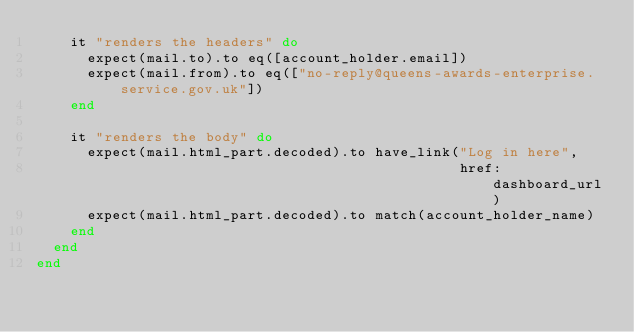<code> <loc_0><loc_0><loc_500><loc_500><_Ruby_>    it "renders the headers" do
      expect(mail.to).to eq([account_holder.email])
      expect(mail.from).to eq(["no-reply@queens-awards-enterprise.service.gov.uk"])
    end

    it "renders the body" do
      expect(mail.html_part.decoded).to have_link("Log in here",
                                                  href: dashboard_url)
      expect(mail.html_part.decoded).to match(account_holder_name)
    end
  end
end
</code> 